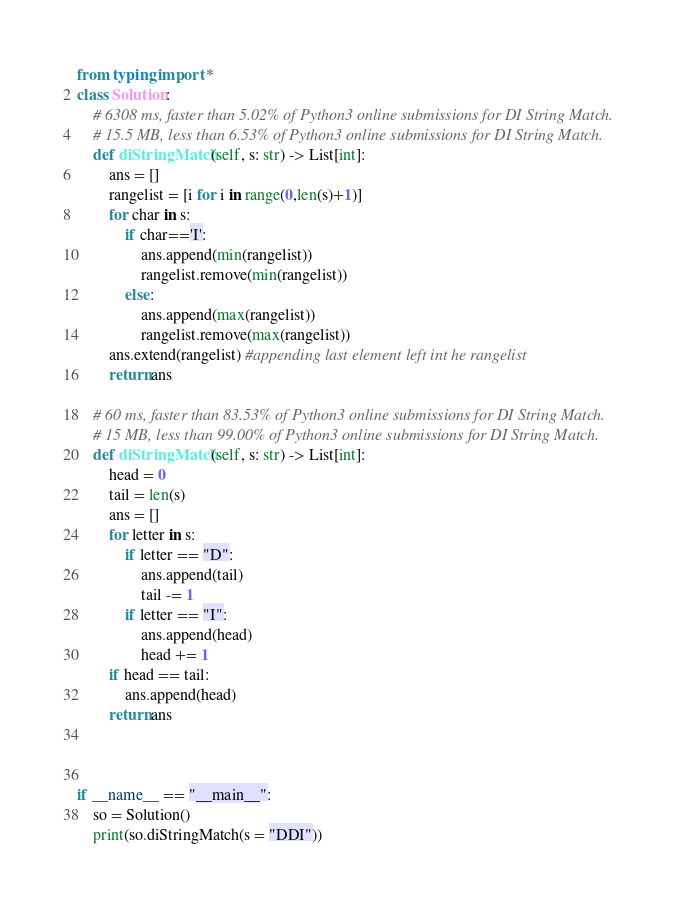Convert code to text. <code><loc_0><loc_0><loc_500><loc_500><_Python_>from typing import *
class Solution:
    # 6308 ms, faster than 5.02% of Python3 online submissions for DI String Match.
    # 15.5 MB, less than 6.53% of Python3 online submissions for DI String Match.
    def diStringMatch(self, s: str) -> List[int]:
        ans = []
        rangelist = [i for i in range(0,len(s)+1)]
        for char in s:
            if char=='I':
                ans.append(min(rangelist))
                rangelist.remove(min(rangelist))
            else:
                ans.append(max(rangelist))
                rangelist.remove(max(rangelist))
        ans.extend(rangelist) #appending last element left int he rangelist
        return ans

    # 60 ms, faster than 83.53% of Python3 online submissions for DI String Match.
    # 15 MB, less than 99.00% of Python3 online submissions for DI String Match.
    def diStringMatch(self, s: str) -> List[int]:
        head = 0
        tail = len(s)
        ans = []
        for letter in s:
            if letter == "D":
                ans.append(tail)
                tail -= 1
            if letter == "I":
                ans.append(head)
                head += 1
        if head == tail:
            ans.append(head)
        return ans



if __name__ == "__main__":
    so = Solution()
    print(so.diStringMatch(s = "DDI"))</code> 